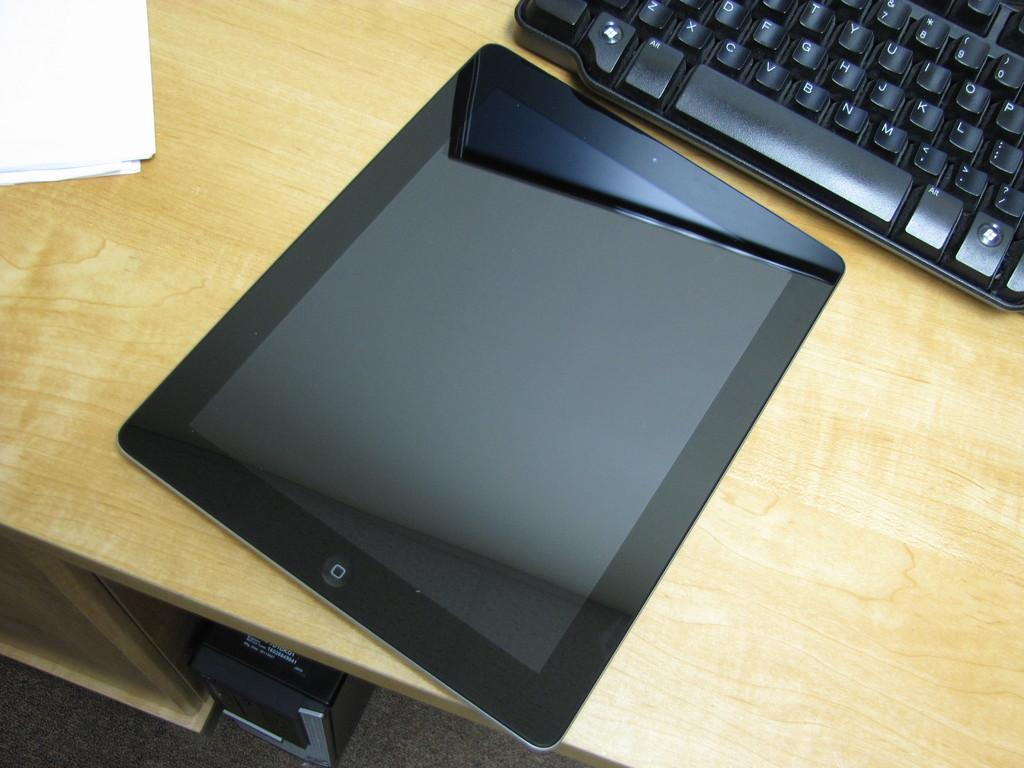<image>
Describe the image concisely. A black keyboard with an ALT key to the left of the space bar.sits behind an iPad. 